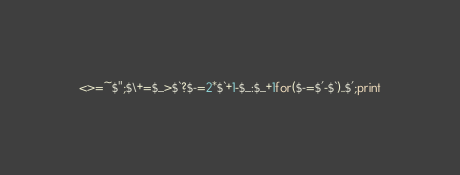<code> <loc_0><loc_0><loc_500><loc_500><_Perl_><>=~$";$\+=$_>$`?$-=2*$`+1-$_:$_+1for($-=$'-$`)..$';print</code> 